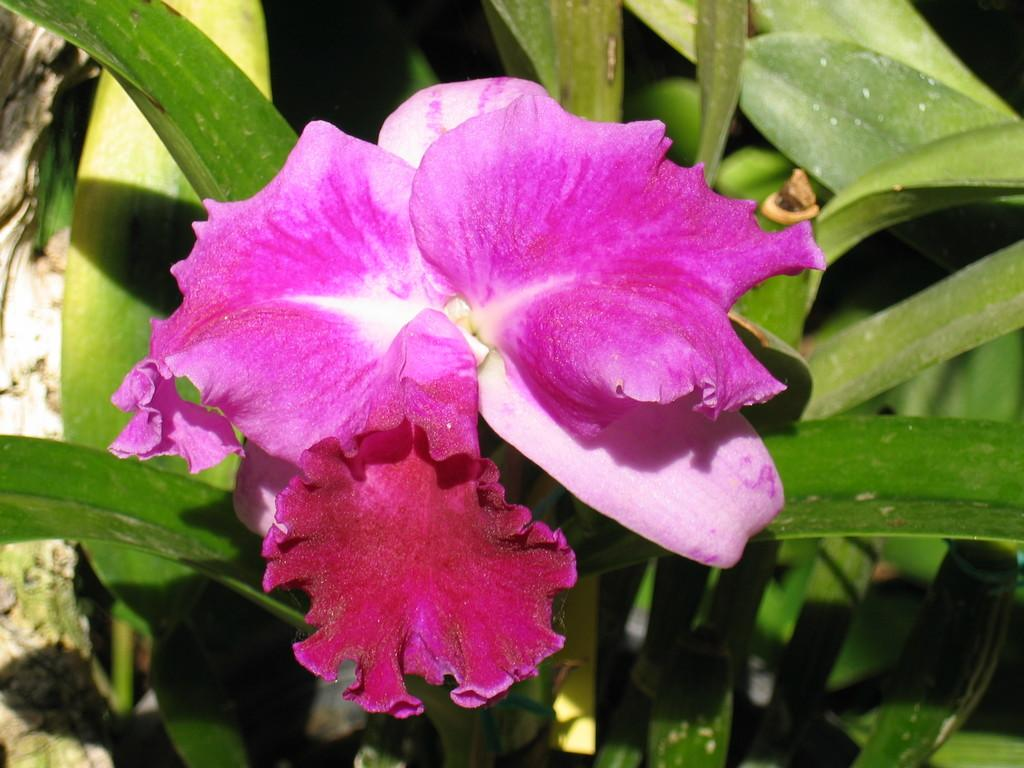What is the main subject of the image? There is a flower in the image. What can be seen in the background of the image? There are leaves visible in the background of the image. How many frogs are sitting on the flower in the image? There are no frogs present in the image. What type of polish is being applied to the flower in the image? There is no polish or any indication of polishing in the image; it features a flower and leaves. 